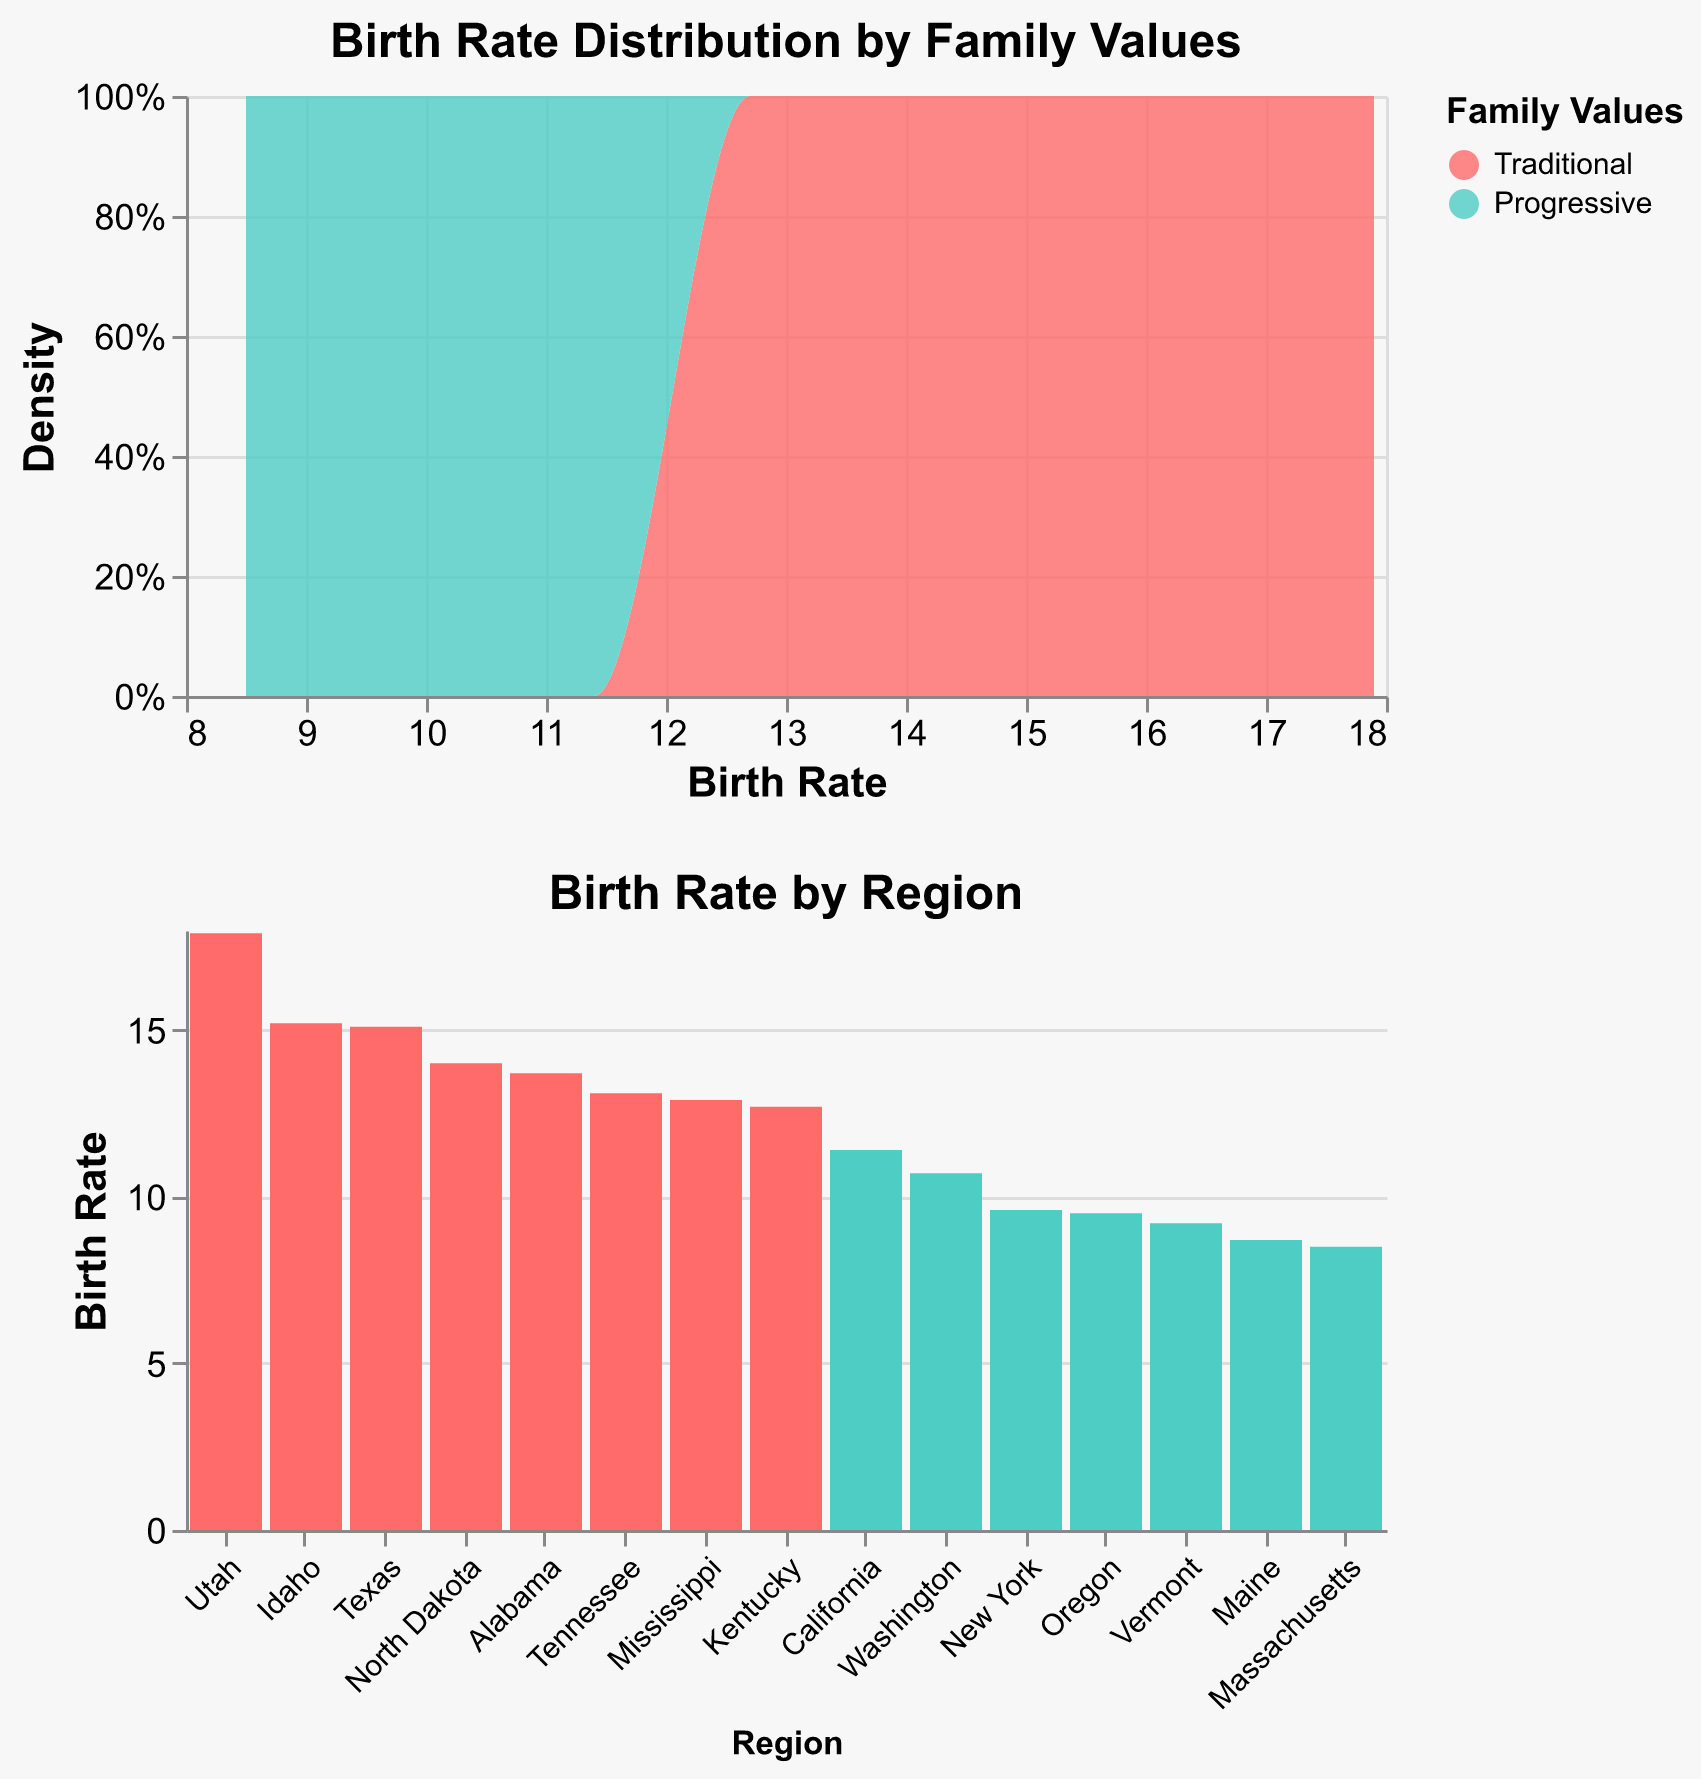What is the title of the distribution plot? The title of the distribution plot is located at the top of the plot, and it summarizes what the plot is showing. It reads "Birth Rate Distribution by Family Values."
Answer: Birth Rate Distribution by Family Values What colors represent Traditional and Progressive family values in the density plot? The colors representing Traditional and Progressive family values are visible in the legend. Traditional is shown in red, and Progressive is shown in teal.
Answer: Traditional: red, Progressive: teal Which region has the highest birth rate according to the bar plot? In the bar plot, the regions are sorted by birth rate, and the heights of the bars indicate the birth rate for each region. Utah has the highest birth rate.
Answer: Utah What is the birth rate for California? The bar plot lists regions along the x-axis, and the height of each bar represents the birth rate. California's bar reaches up to 11.4.
Answer: 11.4 How many regions are categorized as Traditional and how many as Progressive? The color legend and the number of bars in the bar plot help to determine this. Traditional and Progressive regions can be counted by their respective colors. There are 7 Traditional and 6 Progressive regions.
Answer: Traditional: 7, Progressive: 6 What is the range of birth rates for Traditional family values? In the density plot, the range of birth rates for Traditional family values can be observed from the x-axis values covered by the red area. It ranges approximately from 12.7 to 17.9.
Answer: 12.7 to 17.9 Which family values category has a higher birth rate density around 9-12? Observing the density plot, the teal area (Progressive) overlaps with the x-axis values 9-12 more than the red area (Traditional), indicating a higher density for Progressive family values in this range.
Answer: Progressive Are there any regions with birth rates below 8? Both plots show birth rates; checking both reveals that all birth rates are above 8. The bar plot, in particular, makes it clear that all bars start from the bottom at a value above 8.
Answer: No What is the average birth rate for regions with Traditional family values? Looking at the birth rates in the Traditional category: (17.9 + 13.7 + 12.9 + 15.1 + 13.1 + 12.7 + 15.2 + 14.0) and dividing by 8. Sum is 114.6, dividing by 8 gives 14.325.
Answer: 14.325 Compare the birth rate density between Traditional and Progressive family values from 15 to 18. In the density plot, the red area (Traditional) clearly shows density within the range of 15 to 18, while the teal area (Progressive) does not reach this range. Therefore, Traditional has a higher density.
Answer: Traditional 